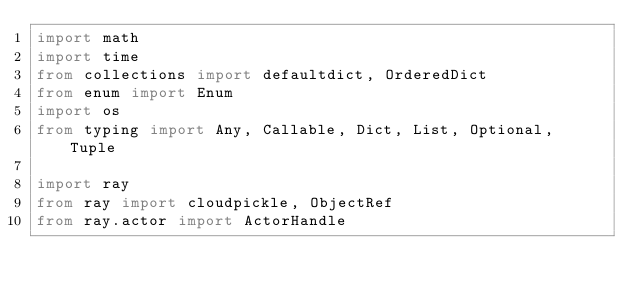Convert code to text. <code><loc_0><loc_0><loc_500><loc_500><_Python_>import math
import time
from collections import defaultdict, OrderedDict
from enum import Enum
import os
from typing import Any, Callable, Dict, List, Optional, Tuple

import ray
from ray import cloudpickle, ObjectRef
from ray.actor import ActorHandle</code> 